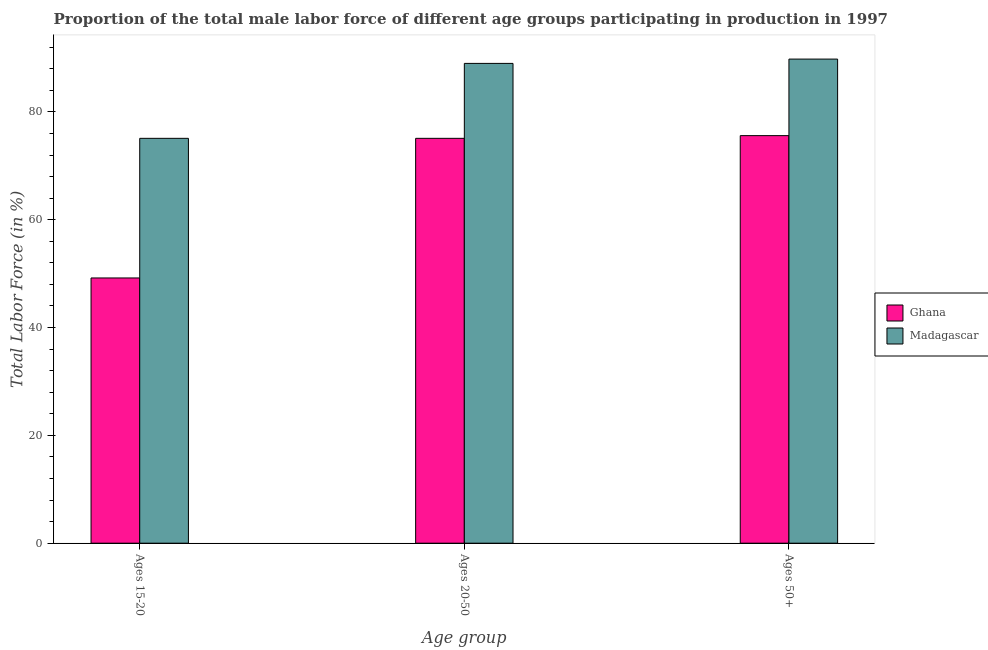How many groups of bars are there?
Provide a short and direct response. 3. Are the number of bars per tick equal to the number of legend labels?
Offer a very short reply. Yes. Are the number of bars on each tick of the X-axis equal?
Your answer should be very brief. Yes. What is the label of the 3rd group of bars from the left?
Offer a very short reply. Ages 50+. What is the percentage of male labor force above age 50 in Madagascar?
Offer a terse response. 89.8. Across all countries, what is the maximum percentage of male labor force within the age group 20-50?
Provide a short and direct response. 89. Across all countries, what is the minimum percentage of male labor force within the age group 20-50?
Give a very brief answer. 75.1. In which country was the percentage of male labor force above age 50 maximum?
Keep it short and to the point. Madagascar. What is the total percentage of male labor force above age 50 in the graph?
Ensure brevity in your answer.  165.4. What is the difference between the percentage of male labor force above age 50 in Ghana and that in Madagascar?
Provide a short and direct response. -14.2. What is the difference between the percentage of male labor force within the age group 15-20 in Ghana and the percentage of male labor force above age 50 in Madagascar?
Give a very brief answer. -40.6. What is the average percentage of male labor force above age 50 per country?
Ensure brevity in your answer.  82.7. What is the difference between the percentage of male labor force within the age group 20-50 and percentage of male labor force within the age group 15-20 in Madagascar?
Ensure brevity in your answer.  13.9. What is the ratio of the percentage of male labor force within the age group 15-20 in Madagascar to that in Ghana?
Your response must be concise. 1.53. Is the difference between the percentage of male labor force within the age group 15-20 in Ghana and Madagascar greater than the difference between the percentage of male labor force within the age group 20-50 in Ghana and Madagascar?
Offer a terse response. No. What is the difference between the highest and the second highest percentage of male labor force above age 50?
Give a very brief answer. 14.2. What is the difference between the highest and the lowest percentage of male labor force within the age group 20-50?
Make the answer very short. 13.9. Is the sum of the percentage of male labor force within the age group 20-50 in Madagascar and Ghana greater than the maximum percentage of male labor force above age 50 across all countries?
Your response must be concise. Yes. What does the 2nd bar from the left in Ages 50+ represents?
Your response must be concise. Madagascar. What does the 1st bar from the right in Ages 20-50 represents?
Offer a very short reply. Madagascar. How many bars are there?
Make the answer very short. 6. How many countries are there in the graph?
Your answer should be compact. 2. What is the difference between two consecutive major ticks on the Y-axis?
Provide a short and direct response. 20. Does the graph contain any zero values?
Your answer should be very brief. No. How many legend labels are there?
Make the answer very short. 2. What is the title of the graph?
Provide a short and direct response. Proportion of the total male labor force of different age groups participating in production in 1997. Does "Greece" appear as one of the legend labels in the graph?
Offer a very short reply. No. What is the label or title of the X-axis?
Your answer should be very brief. Age group. What is the label or title of the Y-axis?
Provide a succinct answer. Total Labor Force (in %). What is the Total Labor Force (in %) in Ghana in Ages 15-20?
Offer a very short reply. 49.2. What is the Total Labor Force (in %) in Madagascar in Ages 15-20?
Offer a terse response. 75.1. What is the Total Labor Force (in %) in Ghana in Ages 20-50?
Your response must be concise. 75.1. What is the Total Labor Force (in %) of Madagascar in Ages 20-50?
Give a very brief answer. 89. What is the Total Labor Force (in %) of Ghana in Ages 50+?
Offer a very short reply. 75.6. What is the Total Labor Force (in %) of Madagascar in Ages 50+?
Give a very brief answer. 89.8. Across all Age group, what is the maximum Total Labor Force (in %) of Ghana?
Your answer should be compact. 75.6. Across all Age group, what is the maximum Total Labor Force (in %) in Madagascar?
Provide a succinct answer. 89.8. Across all Age group, what is the minimum Total Labor Force (in %) in Ghana?
Make the answer very short. 49.2. Across all Age group, what is the minimum Total Labor Force (in %) in Madagascar?
Ensure brevity in your answer.  75.1. What is the total Total Labor Force (in %) of Ghana in the graph?
Ensure brevity in your answer.  199.9. What is the total Total Labor Force (in %) of Madagascar in the graph?
Provide a short and direct response. 253.9. What is the difference between the Total Labor Force (in %) of Ghana in Ages 15-20 and that in Ages 20-50?
Offer a very short reply. -25.9. What is the difference between the Total Labor Force (in %) in Madagascar in Ages 15-20 and that in Ages 20-50?
Give a very brief answer. -13.9. What is the difference between the Total Labor Force (in %) of Ghana in Ages 15-20 and that in Ages 50+?
Offer a very short reply. -26.4. What is the difference between the Total Labor Force (in %) in Madagascar in Ages 15-20 and that in Ages 50+?
Offer a very short reply. -14.7. What is the difference between the Total Labor Force (in %) in Ghana in Ages 15-20 and the Total Labor Force (in %) in Madagascar in Ages 20-50?
Your answer should be very brief. -39.8. What is the difference between the Total Labor Force (in %) in Ghana in Ages 15-20 and the Total Labor Force (in %) in Madagascar in Ages 50+?
Your answer should be very brief. -40.6. What is the difference between the Total Labor Force (in %) in Ghana in Ages 20-50 and the Total Labor Force (in %) in Madagascar in Ages 50+?
Keep it short and to the point. -14.7. What is the average Total Labor Force (in %) in Ghana per Age group?
Offer a very short reply. 66.63. What is the average Total Labor Force (in %) of Madagascar per Age group?
Provide a succinct answer. 84.63. What is the difference between the Total Labor Force (in %) of Ghana and Total Labor Force (in %) of Madagascar in Ages 15-20?
Your response must be concise. -25.9. What is the difference between the Total Labor Force (in %) of Ghana and Total Labor Force (in %) of Madagascar in Ages 20-50?
Provide a succinct answer. -13.9. What is the ratio of the Total Labor Force (in %) of Ghana in Ages 15-20 to that in Ages 20-50?
Make the answer very short. 0.66. What is the ratio of the Total Labor Force (in %) of Madagascar in Ages 15-20 to that in Ages 20-50?
Make the answer very short. 0.84. What is the ratio of the Total Labor Force (in %) in Ghana in Ages 15-20 to that in Ages 50+?
Offer a terse response. 0.65. What is the ratio of the Total Labor Force (in %) of Madagascar in Ages 15-20 to that in Ages 50+?
Give a very brief answer. 0.84. What is the ratio of the Total Labor Force (in %) in Ghana in Ages 20-50 to that in Ages 50+?
Your answer should be compact. 0.99. What is the difference between the highest and the second highest Total Labor Force (in %) in Madagascar?
Make the answer very short. 0.8. What is the difference between the highest and the lowest Total Labor Force (in %) in Ghana?
Your answer should be very brief. 26.4. What is the difference between the highest and the lowest Total Labor Force (in %) in Madagascar?
Give a very brief answer. 14.7. 